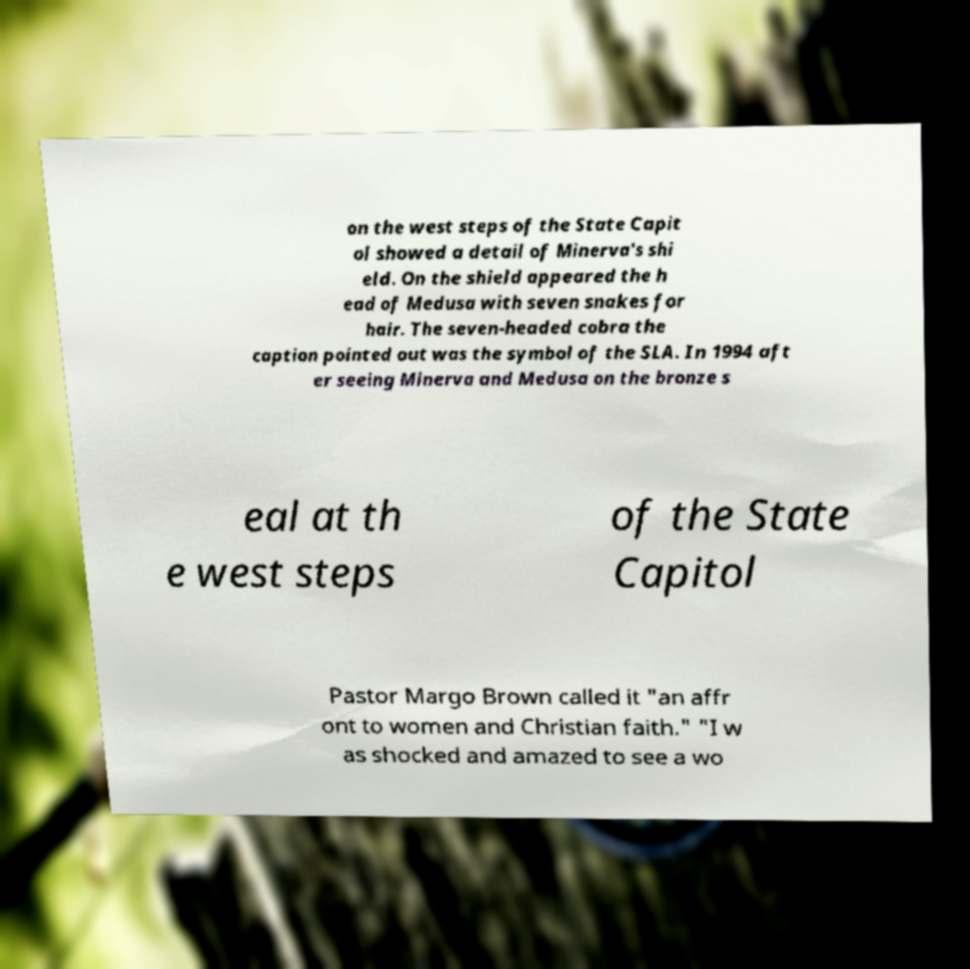Please read and relay the text visible in this image. What does it say? on the west steps of the State Capit ol showed a detail of Minerva's shi eld. On the shield appeared the h ead of Medusa with seven snakes for hair. The seven-headed cobra the caption pointed out was the symbol of the SLA. In 1994 aft er seeing Minerva and Medusa on the bronze s eal at th e west steps of the State Capitol Pastor Margo Brown called it "an affr ont to women and Christian faith." "I w as shocked and amazed to see a wo 